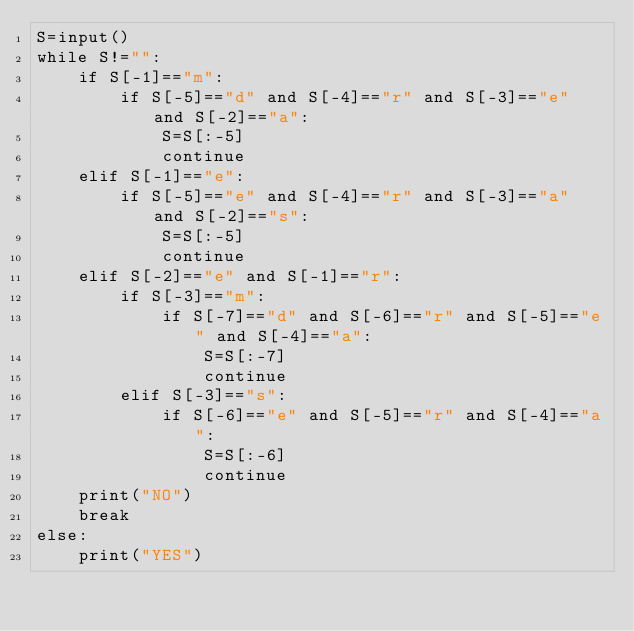Convert code to text. <code><loc_0><loc_0><loc_500><loc_500><_Python_>S=input()
while S!="":
    if S[-1]=="m":
        if S[-5]=="d" and S[-4]=="r" and S[-3]=="e" and S[-2]=="a":
            S=S[:-5]
            continue
    elif S[-1]=="e":
        if S[-5]=="e" and S[-4]=="r" and S[-3]=="a" and S[-2]=="s":
            S=S[:-5]
            continue
    elif S[-2]=="e" and S[-1]=="r":
        if S[-3]=="m":
            if S[-7]=="d" and S[-6]=="r" and S[-5]=="e" and S[-4]=="a":
                S=S[:-7]
                continue
        elif S[-3]=="s":
            if S[-6]=="e" and S[-5]=="r" and S[-4]=="a":
                S=S[:-6]
                continue
    print("NO")
    break
else:
    print("YES")</code> 